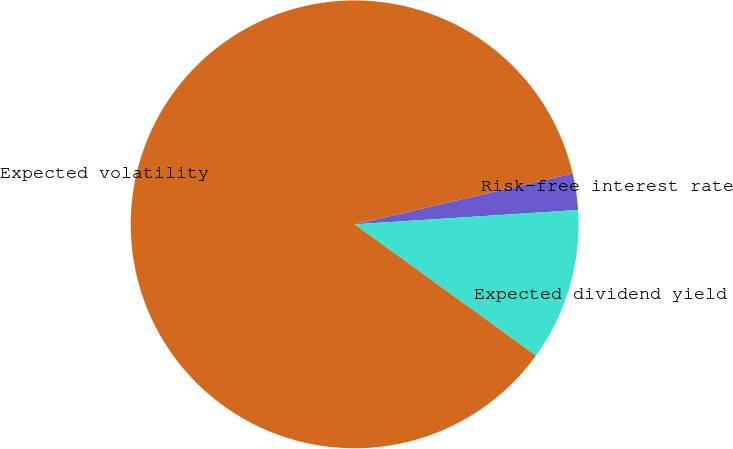<chart> <loc_0><loc_0><loc_500><loc_500><pie_chart><fcel>Risk-free interest rate<fcel>Expected dividend yield<fcel>Expected volatility<nl><fcel>2.63%<fcel>11.0%<fcel>86.37%<nl></chart> 